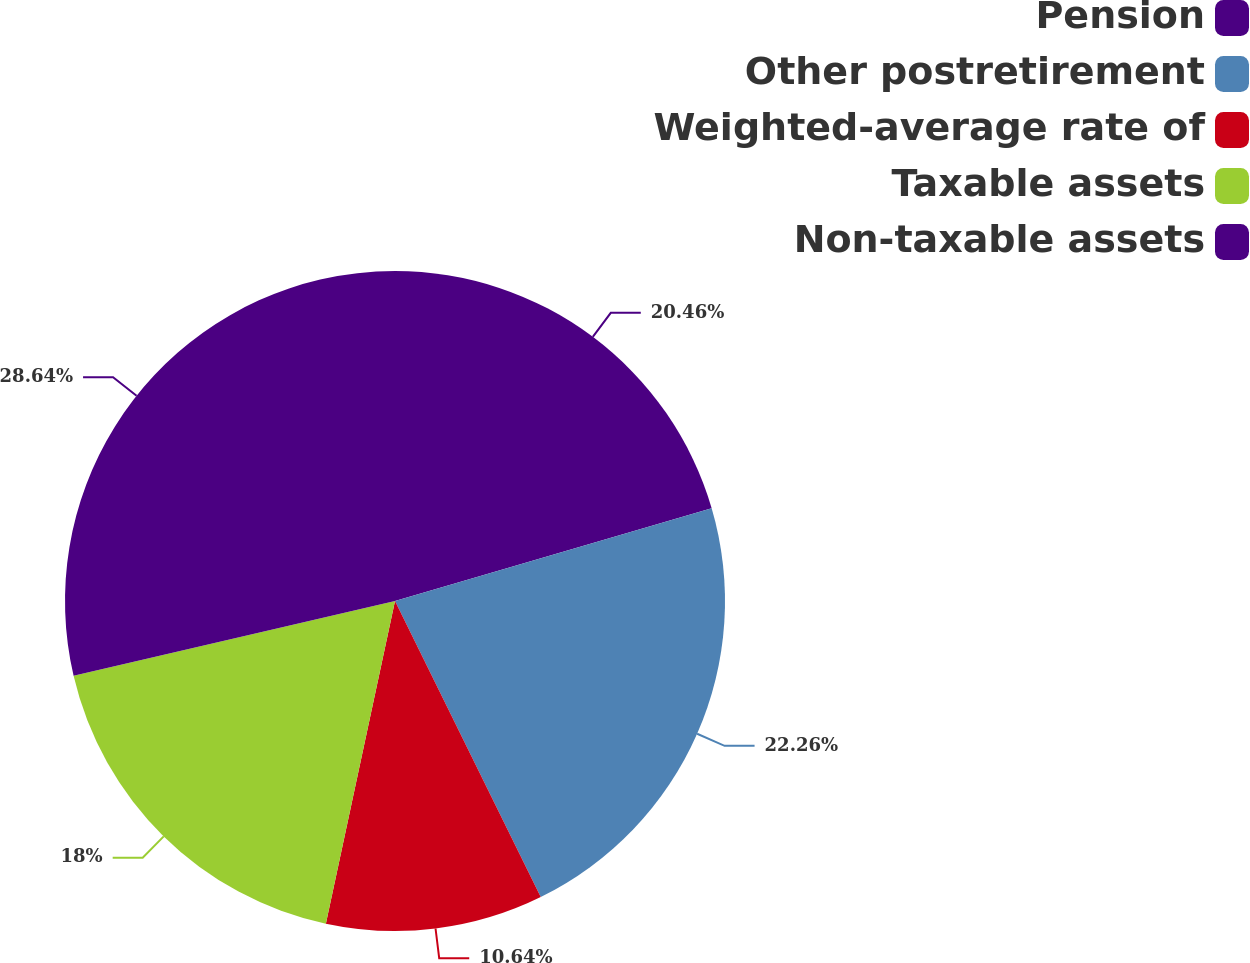<chart> <loc_0><loc_0><loc_500><loc_500><pie_chart><fcel>Pension<fcel>Other postretirement<fcel>Weighted-average rate of<fcel>Taxable assets<fcel>Non-taxable assets<nl><fcel>20.46%<fcel>22.26%<fcel>10.64%<fcel>18.0%<fcel>28.64%<nl></chart> 